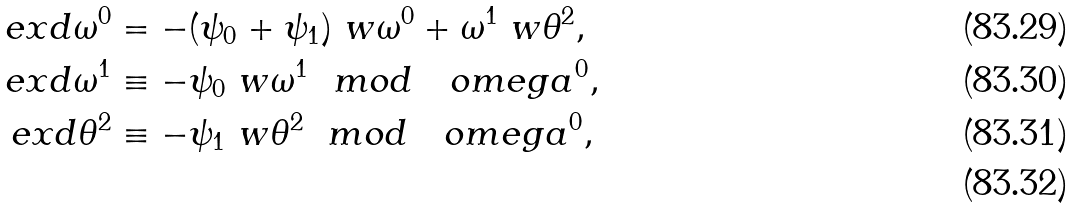<formula> <loc_0><loc_0><loc_500><loc_500>\ e x d \omega ^ { 0 } & = - ( \psi _ { 0 } + \psi _ { 1 } ) \ w \omega ^ { 0 } + \omega ^ { 1 } \ w \theta ^ { 2 } , \\ \ e x d \omega ^ { 1 } & \equiv - \psi _ { 0 } \ w \omega ^ { 1 } \ \ m o d \quad o m e g a ^ { 0 } , \\ \ e x d \theta ^ { 2 } & \equiv - \psi _ { 1 } \ w \theta ^ { 2 } \ \ m o d \quad o m e g a ^ { 0 } , \\</formula> 